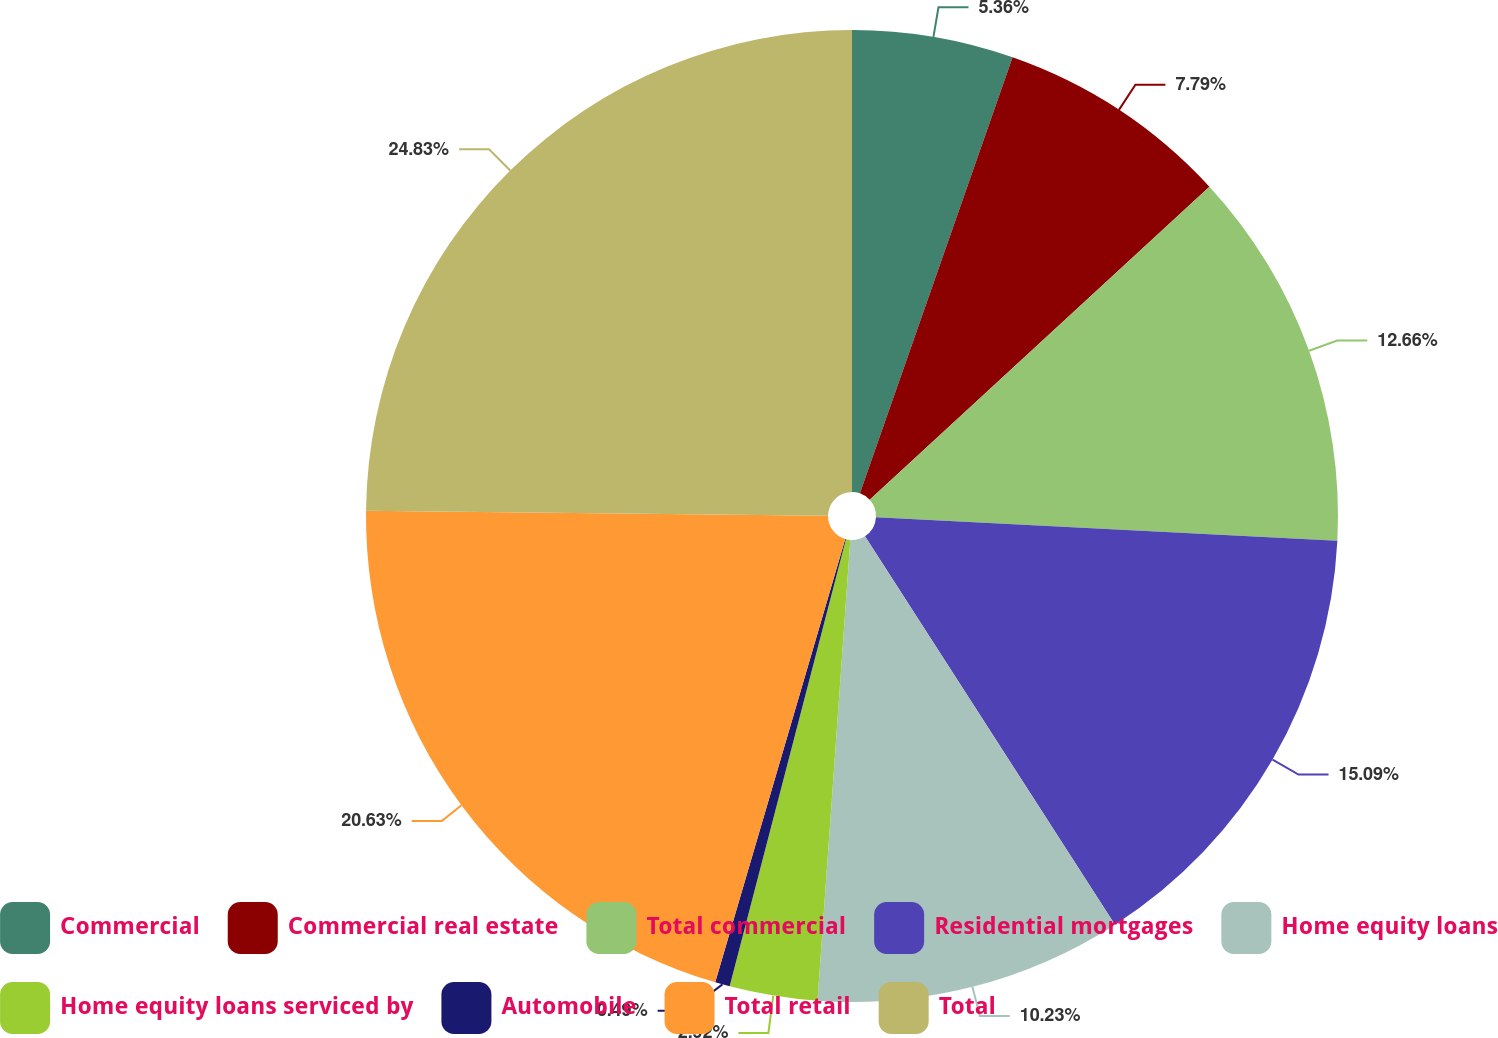<chart> <loc_0><loc_0><loc_500><loc_500><pie_chart><fcel>Commercial<fcel>Commercial real estate<fcel>Total commercial<fcel>Residential mortgages<fcel>Home equity loans<fcel>Home equity loans serviced by<fcel>Automobile<fcel>Total retail<fcel>Total<nl><fcel>5.36%<fcel>7.79%<fcel>12.66%<fcel>15.09%<fcel>10.23%<fcel>2.92%<fcel>0.49%<fcel>20.63%<fcel>24.83%<nl></chart> 